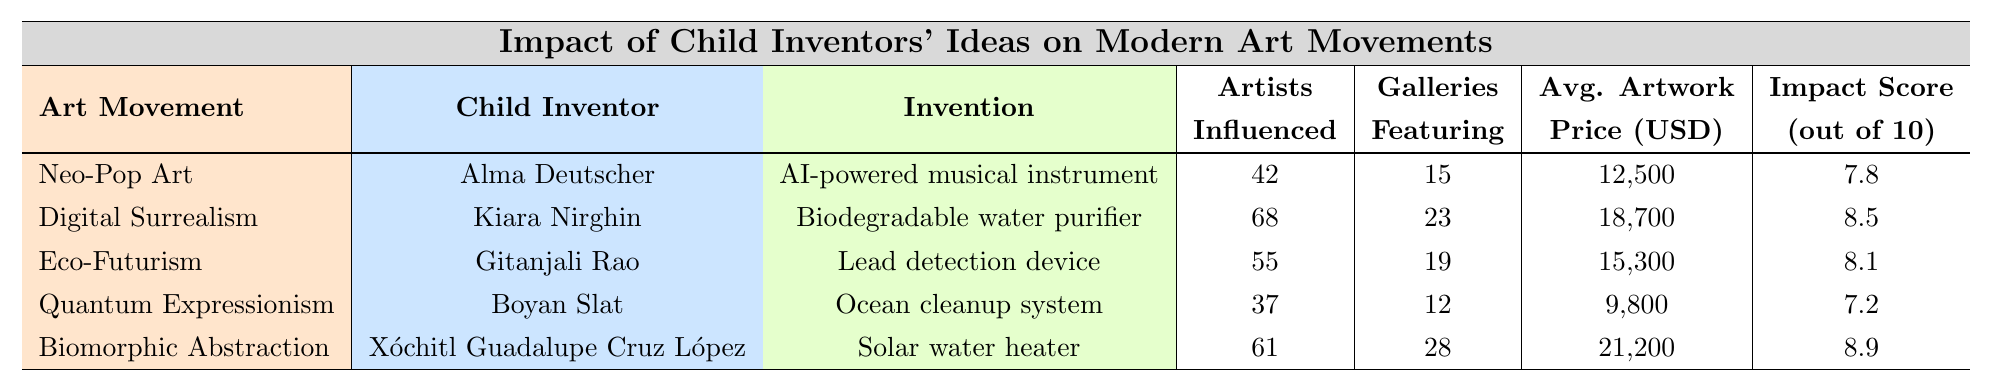What is the highest impact score among the inventions listed? The impact scores are given as 7.8, 8.5, 8.1, 7.2, and 8.9. The highest value is 8.9.
Answer: 8.9 Who is the child inventor associated with Eco-Futurism? The table lists the child inventors and their corresponding art movements. Eco-Futurism is associated with Gitanjali Rao.
Answer: Gitanjali Rao What was the average artwork price for Digital Surrealism? The average artwork price for Digital Surrealism is listed as 18,700 USD directly in the table.
Answer: 18,700 USD How many artists were influenced by the invention of the Ocean cleanup system? The table indicates that 37 artists were influenced by the invention of the Ocean cleanup system.
Answer: 37 Which child inventor's invention had the highest number of galleries featuring related art? The table shows that Xóchitl Guadalupe Cruz López’s invention, the Solar water heater, had 28 galleries featuring related art, which is the highest number.
Answer: Xóchitl Guadalupe Cruz López What is the percentage of positive reception for Biodegradable water purifier? The table states that the percentage of positive reception for the Biodegradable water purifier is 89%.
Answer: 89% What is the difference in the number of artists influenced by Neo-Pop Art and Quantum Expressionism? Neo-Pop Art influenced 42 artists and Quantum Expressionism influenced 37 artists. The difference is 42 - 37 = 5.
Answer: 5 How many exhibitions were organized in total for the inventions listed? Adding the number of exhibitions organized: 5 + 9 + 7 + 4 + 11 = 36.
Answer: 36 Which invention had the lowest average artwork price and what was that price? The Ocean cleanup system had the lowest average artwork price listed at 9,800 USD.
Answer: 9,800 USD True or False: The invention with the highest impact score is also the one that influenced the most artists. The highest impact score (8.9) is for the Solar water heater, which influenced 61 artists. The highest number of artists influenced belongs to the Biodegradable water purifier with 68 artists, thus the statement is false.
Answer: False What is the average impact score of the inventions listed? The impact scores are 7.8, 8.5, 8.1, 7.2, and 8.9. Their average is (7.8 + 8.5 + 8.1 + 7.2 + 8.9) / 5 = 8.1.
Answer: 8.1 